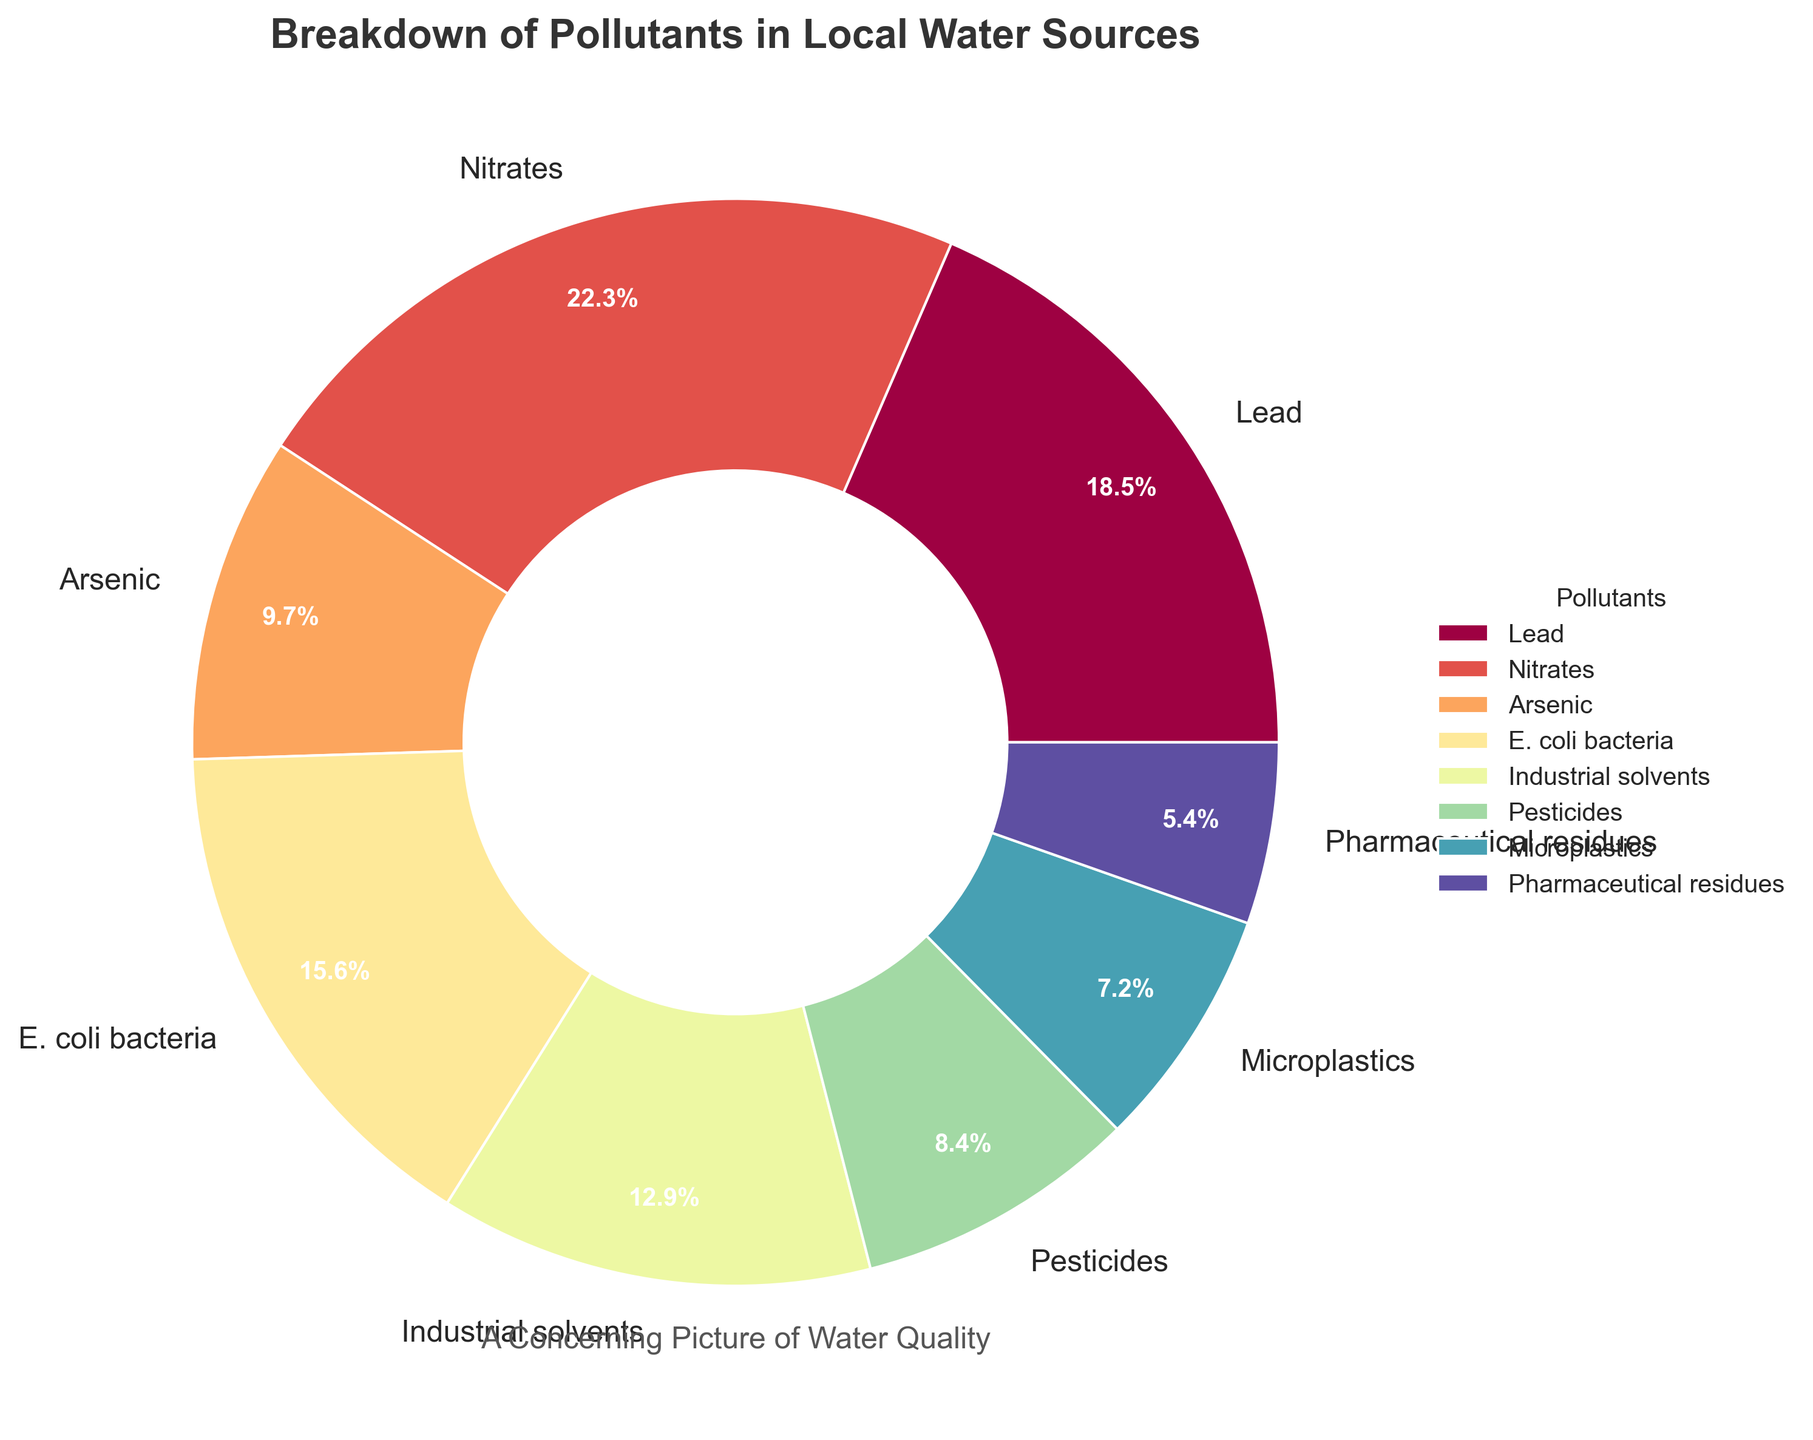What pollutant has the highest percentage? The pollutant with the highest percentage would be the one occupying the largest visual segment of the pie chart, which is labeled and shows the percentage value. From the chart, we can see that Nitrates make up 22.3% of the total pollutants.
Answer: Nitrates What is the sum of the percentages of E. coli bacteria and Lead? To find the sum of the percentages of E. coli bacteria and Lead, add their respective values. E. coli bacteria is 15.6% and Lead is 18.5%. So, 15.6 + 18.5 = 34.1%.
Answer: 34.1% Which pollutant has the smallest percentage? The pollutant with the smallest percentage would occupy the smallest segment of the pie chart. From the chart, Pharmaceutical residues are represented by only 5.4%.
Answer: Pharmaceutical residues How much more percentage does Industrial solvents have compared to Microplastics? To find out how much more Industrial solvents have compared to Microplastics, subtract the percentage of Microplastics from the percentage of Industrial solvents. Industrial solvents have 12.9% and Microplastics have 7.2%. So, 12.9 - 7.2 = 5.7%.
Answer: 5.7% Which pollutants make up more than 10% of the total? The pollutants that make up more than 10% of the total are those whose corresponding pie segments show values exceeding 10%. These are Nitrates (22.3%), Lead (18.5%), E. coli bacteria (15.6%), and Industrial solvents (12.9%).
Answer: Nitrates, Lead, E. coli bacteria, Industrial solvents What is the difference in percentage between Pesticides and Arsenic? To determine the difference in percentage between Pesticides and Arsenic, subtract the smaller percentage from the larger one. Arsenic is 9.7% and Pesticides are 8.4%. So, 9.7 - 8.4 = 1.3%.
Answer: 1.3% What is the total percentage of pollutants classified under ‘Heavy Metals’ (Lead and Arsenic)? Add the percentages of Lead and Arsenic to get the total percentage for ‘Heavy Metals’. Lead has 18.5% and Arsenic has 9.7%. So, 18.5 + 9.7 = 28.2%.
Answer: 28.2% Which pollutant segment is visually represented with the color closest to red? While coding specifics for the color palette aren't provided, visually we should look for the segment whose color appears closest to a red shade based on common palettes. Let's assume Lead's segment appears closest to red in the Spectral colormap.
Answer: Lead What is the combined percentage of all pollutants not exceeding 10% individually? Add the percentages of all pollutants with values less than or equal to 10%. These are Arsenic (9.7%), Pesticides (8.4%), Microplastics (7.2%), and Pharmaceutical residues (5.4%). So, 9.7 + 8.4 + 7.2 + 5.4 = 30.7%.
Answer: 30.7% Which is greater: the percentage of E. coli bacteria or the combined percentage of Microplastics and Pharmaceutical residues? First, find the combined percentage of Microplastics and Pharmaceutical residues: 7.2 + 5.4 = 12.6%. Then compare it to the percentage of E. coli bacteria, which is 15.6%. Since 15.6% is greater than 12.6%, E. coli bacteria has a higher individual percentage.
Answer: E. coli bacteria 